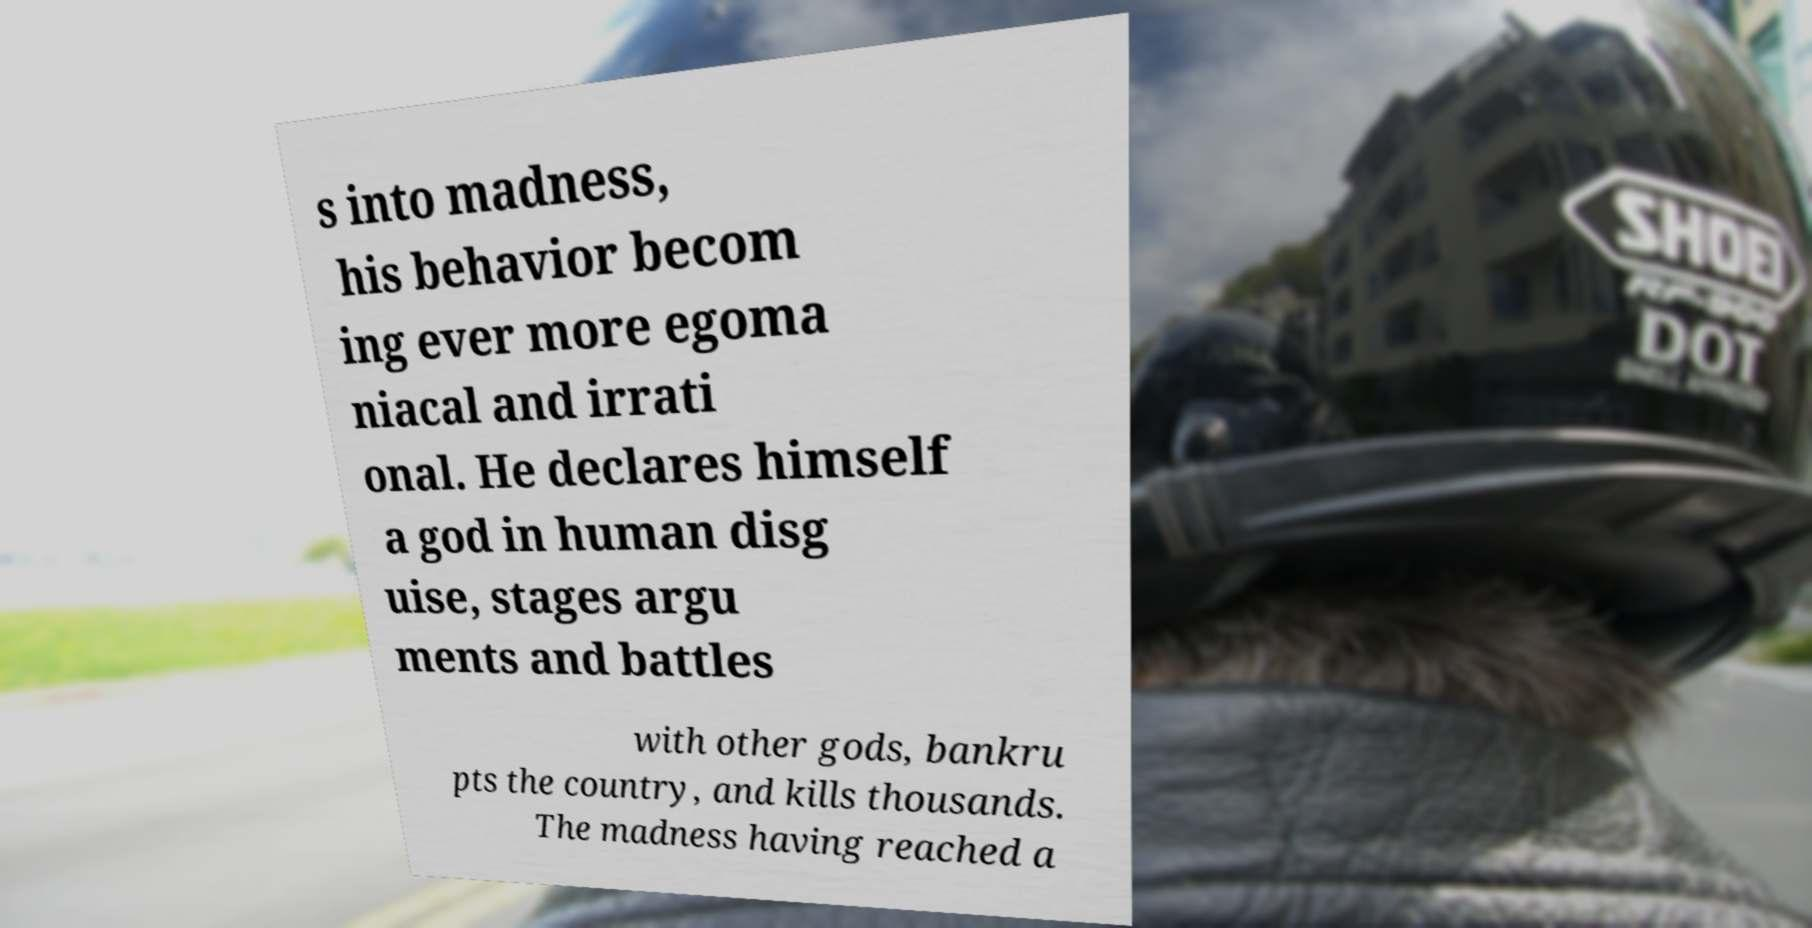Could you assist in decoding the text presented in this image and type it out clearly? s into madness, his behavior becom ing ever more egoma niacal and irrati onal. He declares himself a god in human disg uise, stages argu ments and battles with other gods, bankru pts the country, and kills thousands. The madness having reached a 